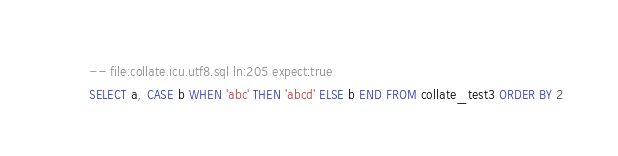<code> <loc_0><loc_0><loc_500><loc_500><_SQL_>-- file:collate.icu.utf8.sql ln:205 expect:true
SELECT a, CASE b WHEN 'abc' THEN 'abcd' ELSE b END FROM collate_test3 ORDER BY 2
</code> 